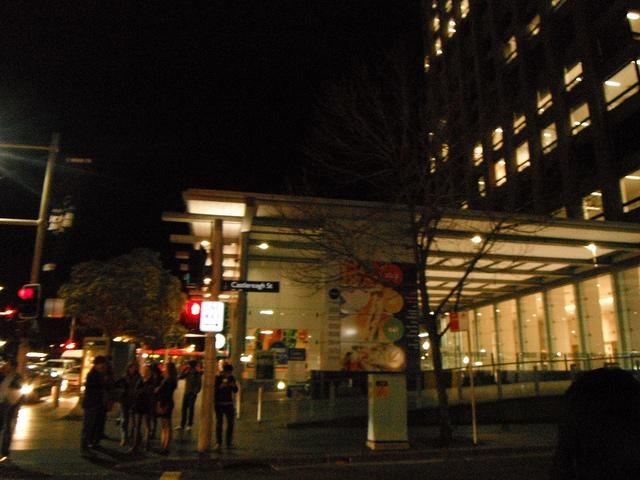What are the people waiting to do? Please explain your reasoning. cross. The people want to get over to the other side of the street. 